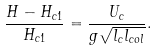<formula> <loc_0><loc_0><loc_500><loc_500>\frac { H - H _ { c 1 } } { H _ { c 1 } } = \frac { U _ { c } } { g \sqrt { l _ { c } l _ { c o l } } } .</formula> 